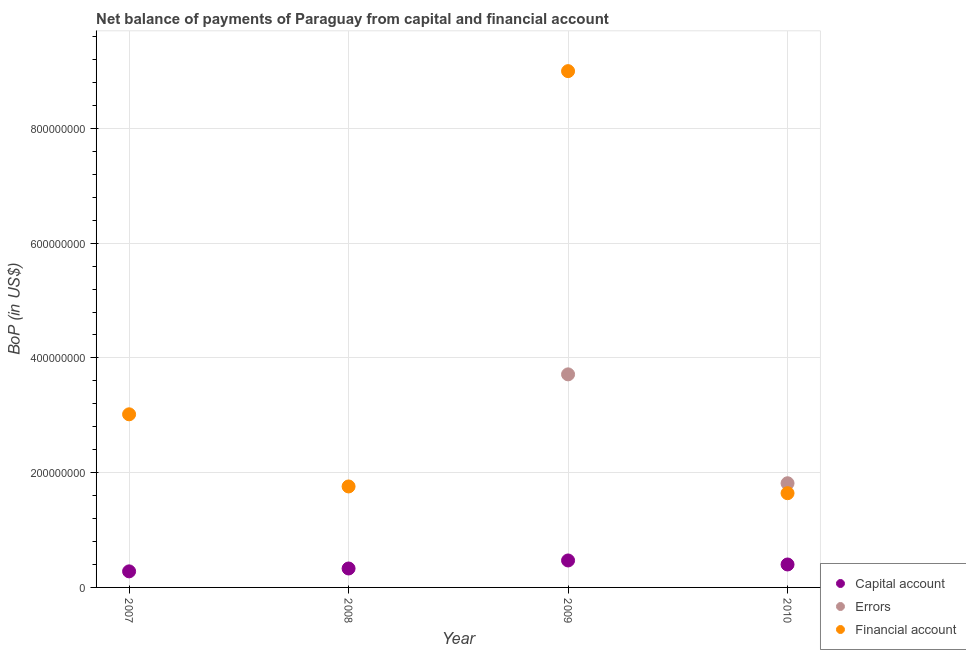How many different coloured dotlines are there?
Provide a succinct answer. 3. What is the amount of financial account in 2009?
Make the answer very short. 9.00e+08. Across all years, what is the maximum amount of errors?
Provide a succinct answer. 3.71e+08. Across all years, what is the minimum amount of errors?
Make the answer very short. 0. In which year was the amount of errors maximum?
Offer a very short reply. 2009. What is the total amount of net capital account in the graph?
Provide a succinct answer. 1.48e+08. What is the difference between the amount of financial account in 2008 and that in 2009?
Provide a short and direct response. -7.24e+08. What is the difference between the amount of errors in 2009 and the amount of financial account in 2008?
Keep it short and to the point. 1.95e+08. What is the average amount of errors per year?
Make the answer very short. 1.38e+08. In the year 2008, what is the difference between the amount of financial account and amount of net capital account?
Provide a succinct answer. 1.43e+08. In how many years, is the amount of errors greater than 880000000 US$?
Make the answer very short. 0. What is the ratio of the amount of financial account in 2008 to that in 2009?
Your response must be concise. 0.2. Is the difference between the amount of financial account in 2009 and 2010 greater than the difference between the amount of errors in 2009 and 2010?
Make the answer very short. Yes. What is the difference between the highest and the second highest amount of financial account?
Your answer should be compact. 5.98e+08. What is the difference between the highest and the lowest amount of errors?
Your answer should be very brief. 3.71e+08. Is the sum of the amount of financial account in 2008 and 2009 greater than the maximum amount of errors across all years?
Your answer should be very brief. Yes. Is the amount of net capital account strictly greater than the amount of financial account over the years?
Keep it short and to the point. No. Is the amount of net capital account strictly less than the amount of financial account over the years?
Make the answer very short. Yes. How many dotlines are there?
Keep it short and to the point. 3. How many years are there in the graph?
Your answer should be very brief. 4. Are the values on the major ticks of Y-axis written in scientific E-notation?
Your answer should be very brief. No. Does the graph contain any zero values?
Provide a short and direct response. Yes. Does the graph contain grids?
Your response must be concise. Yes. How many legend labels are there?
Keep it short and to the point. 3. What is the title of the graph?
Your answer should be very brief. Net balance of payments of Paraguay from capital and financial account. Does "Ages 60+" appear as one of the legend labels in the graph?
Your answer should be very brief. No. What is the label or title of the Y-axis?
Keep it short and to the point. BoP (in US$). What is the BoP (in US$) of Capital account in 2007?
Provide a succinct answer. 2.80e+07. What is the BoP (in US$) of Financial account in 2007?
Your answer should be compact. 3.02e+08. What is the BoP (in US$) in Capital account in 2008?
Your response must be concise. 3.30e+07. What is the BoP (in US$) in Errors in 2008?
Make the answer very short. 0. What is the BoP (in US$) in Financial account in 2008?
Provide a succinct answer. 1.76e+08. What is the BoP (in US$) in Capital account in 2009?
Make the answer very short. 4.70e+07. What is the BoP (in US$) of Errors in 2009?
Provide a short and direct response. 3.71e+08. What is the BoP (in US$) of Financial account in 2009?
Give a very brief answer. 9.00e+08. What is the BoP (in US$) of Capital account in 2010?
Offer a terse response. 4.00e+07. What is the BoP (in US$) in Errors in 2010?
Ensure brevity in your answer.  1.82e+08. What is the BoP (in US$) in Financial account in 2010?
Give a very brief answer. 1.64e+08. Across all years, what is the maximum BoP (in US$) in Capital account?
Your answer should be compact. 4.70e+07. Across all years, what is the maximum BoP (in US$) in Errors?
Your answer should be compact. 3.71e+08. Across all years, what is the maximum BoP (in US$) in Financial account?
Keep it short and to the point. 9.00e+08. Across all years, what is the minimum BoP (in US$) in Capital account?
Provide a succinct answer. 2.80e+07. Across all years, what is the minimum BoP (in US$) of Errors?
Make the answer very short. 0. Across all years, what is the minimum BoP (in US$) in Financial account?
Your answer should be very brief. 1.64e+08. What is the total BoP (in US$) of Capital account in the graph?
Your answer should be compact. 1.48e+08. What is the total BoP (in US$) in Errors in the graph?
Make the answer very short. 5.53e+08. What is the total BoP (in US$) in Financial account in the graph?
Your answer should be compact. 1.54e+09. What is the difference between the BoP (in US$) of Capital account in 2007 and that in 2008?
Your answer should be very brief. -5.00e+06. What is the difference between the BoP (in US$) of Financial account in 2007 and that in 2008?
Provide a short and direct response. 1.26e+08. What is the difference between the BoP (in US$) of Capital account in 2007 and that in 2009?
Your response must be concise. -1.90e+07. What is the difference between the BoP (in US$) in Financial account in 2007 and that in 2009?
Make the answer very short. -5.98e+08. What is the difference between the BoP (in US$) of Capital account in 2007 and that in 2010?
Offer a terse response. -1.20e+07. What is the difference between the BoP (in US$) of Financial account in 2007 and that in 2010?
Ensure brevity in your answer.  1.37e+08. What is the difference between the BoP (in US$) in Capital account in 2008 and that in 2009?
Offer a very short reply. -1.40e+07. What is the difference between the BoP (in US$) in Financial account in 2008 and that in 2009?
Keep it short and to the point. -7.24e+08. What is the difference between the BoP (in US$) of Capital account in 2008 and that in 2010?
Your answer should be very brief. -7.00e+06. What is the difference between the BoP (in US$) of Financial account in 2008 and that in 2010?
Provide a short and direct response. 1.17e+07. What is the difference between the BoP (in US$) in Capital account in 2009 and that in 2010?
Make the answer very short. 7.00e+06. What is the difference between the BoP (in US$) in Errors in 2009 and that in 2010?
Offer a terse response. 1.90e+08. What is the difference between the BoP (in US$) of Financial account in 2009 and that in 2010?
Make the answer very short. 7.36e+08. What is the difference between the BoP (in US$) in Capital account in 2007 and the BoP (in US$) in Financial account in 2008?
Offer a very short reply. -1.48e+08. What is the difference between the BoP (in US$) of Capital account in 2007 and the BoP (in US$) of Errors in 2009?
Your answer should be compact. -3.43e+08. What is the difference between the BoP (in US$) of Capital account in 2007 and the BoP (in US$) of Financial account in 2009?
Give a very brief answer. -8.72e+08. What is the difference between the BoP (in US$) in Capital account in 2007 and the BoP (in US$) in Errors in 2010?
Provide a succinct answer. -1.54e+08. What is the difference between the BoP (in US$) of Capital account in 2007 and the BoP (in US$) of Financial account in 2010?
Make the answer very short. -1.36e+08. What is the difference between the BoP (in US$) of Capital account in 2008 and the BoP (in US$) of Errors in 2009?
Ensure brevity in your answer.  -3.38e+08. What is the difference between the BoP (in US$) of Capital account in 2008 and the BoP (in US$) of Financial account in 2009?
Keep it short and to the point. -8.67e+08. What is the difference between the BoP (in US$) in Capital account in 2008 and the BoP (in US$) in Errors in 2010?
Your response must be concise. -1.49e+08. What is the difference between the BoP (in US$) of Capital account in 2008 and the BoP (in US$) of Financial account in 2010?
Provide a short and direct response. -1.31e+08. What is the difference between the BoP (in US$) in Capital account in 2009 and the BoP (in US$) in Errors in 2010?
Give a very brief answer. -1.35e+08. What is the difference between the BoP (in US$) in Capital account in 2009 and the BoP (in US$) in Financial account in 2010?
Keep it short and to the point. -1.17e+08. What is the difference between the BoP (in US$) of Errors in 2009 and the BoP (in US$) of Financial account in 2010?
Your answer should be compact. 2.07e+08. What is the average BoP (in US$) of Capital account per year?
Provide a short and direct response. 3.70e+07. What is the average BoP (in US$) of Errors per year?
Your response must be concise. 1.38e+08. What is the average BoP (in US$) of Financial account per year?
Your answer should be compact. 3.85e+08. In the year 2007, what is the difference between the BoP (in US$) in Capital account and BoP (in US$) in Financial account?
Your response must be concise. -2.74e+08. In the year 2008, what is the difference between the BoP (in US$) of Capital account and BoP (in US$) of Financial account?
Your answer should be very brief. -1.43e+08. In the year 2009, what is the difference between the BoP (in US$) of Capital account and BoP (in US$) of Errors?
Give a very brief answer. -3.24e+08. In the year 2009, what is the difference between the BoP (in US$) of Capital account and BoP (in US$) of Financial account?
Offer a very short reply. -8.53e+08. In the year 2009, what is the difference between the BoP (in US$) of Errors and BoP (in US$) of Financial account?
Offer a very short reply. -5.29e+08. In the year 2010, what is the difference between the BoP (in US$) of Capital account and BoP (in US$) of Errors?
Keep it short and to the point. -1.42e+08. In the year 2010, what is the difference between the BoP (in US$) of Capital account and BoP (in US$) of Financial account?
Provide a short and direct response. -1.24e+08. In the year 2010, what is the difference between the BoP (in US$) of Errors and BoP (in US$) of Financial account?
Offer a terse response. 1.73e+07. What is the ratio of the BoP (in US$) of Capital account in 2007 to that in 2008?
Give a very brief answer. 0.85. What is the ratio of the BoP (in US$) of Financial account in 2007 to that in 2008?
Provide a succinct answer. 1.71. What is the ratio of the BoP (in US$) of Capital account in 2007 to that in 2009?
Your answer should be compact. 0.6. What is the ratio of the BoP (in US$) of Financial account in 2007 to that in 2009?
Ensure brevity in your answer.  0.34. What is the ratio of the BoP (in US$) of Capital account in 2007 to that in 2010?
Keep it short and to the point. 0.7. What is the ratio of the BoP (in US$) in Financial account in 2007 to that in 2010?
Your response must be concise. 1.84. What is the ratio of the BoP (in US$) of Capital account in 2008 to that in 2009?
Ensure brevity in your answer.  0.7. What is the ratio of the BoP (in US$) in Financial account in 2008 to that in 2009?
Offer a terse response. 0.2. What is the ratio of the BoP (in US$) of Capital account in 2008 to that in 2010?
Offer a terse response. 0.82. What is the ratio of the BoP (in US$) of Financial account in 2008 to that in 2010?
Your answer should be very brief. 1.07. What is the ratio of the BoP (in US$) of Capital account in 2009 to that in 2010?
Your answer should be very brief. 1.18. What is the ratio of the BoP (in US$) of Errors in 2009 to that in 2010?
Make the answer very short. 2.05. What is the ratio of the BoP (in US$) in Financial account in 2009 to that in 2010?
Provide a short and direct response. 5.48. What is the difference between the highest and the second highest BoP (in US$) in Capital account?
Offer a very short reply. 7.00e+06. What is the difference between the highest and the second highest BoP (in US$) in Financial account?
Your answer should be very brief. 5.98e+08. What is the difference between the highest and the lowest BoP (in US$) in Capital account?
Offer a terse response. 1.90e+07. What is the difference between the highest and the lowest BoP (in US$) in Errors?
Make the answer very short. 3.71e+08. What is the difference between the highest and the lowest BoP (in US$) of Financial account?
Provide a succinct answer. 7.36e+08. 